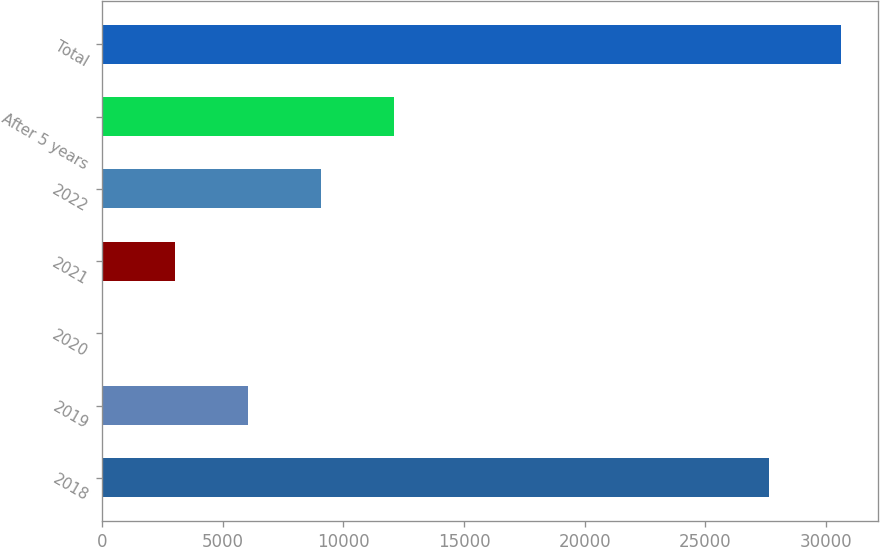<chart> <loc_0><loc_0><loc_500><loc_500><bar_chart><fcel>2018<fcel>2019<fcel>2020<fcel>2021<fcel>2022<fcel>After 5 years<fcel>Total<nl><fcel>27621<fcel>6049.2<fcel>22<fcel>3035.6<fcel>9062.8<fcel>12076.4<fcel>30634.6<nl></chart> 